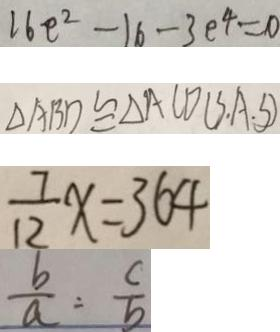Convert formula to latex. <formula><loc_0><loc_0><loc_500><loc_500>1 6 e ^ { 2 } - 1 6 - 3 e ^ { 4 } = 0 
 \Delta A B D \cong \Delta A C D ( S A . S ) 
 \frac { 7 } { 1 2 } x = 3 6 4 
 \frac { b } { a } = \frac { c } { b }</formula> 